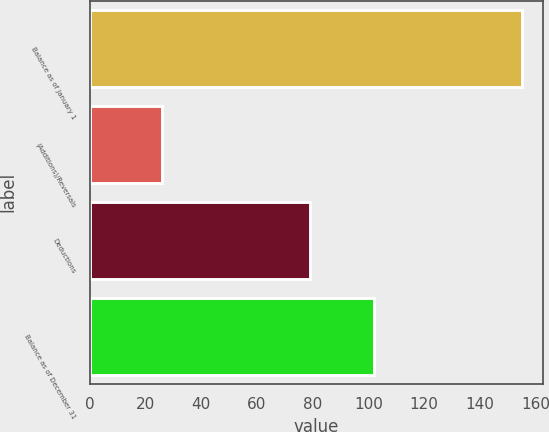Convert chart. <chart><loc_0><loc_0><loc_500><loc_500><bar_chart><fcel>Balance as of January 1<fcel>(Additions)/Reversals<fcel>Deductions<fcel>Balance as of December 31<nl><fcel>155<fcel>26<fcel>79<fcel>102<nl></chart> 